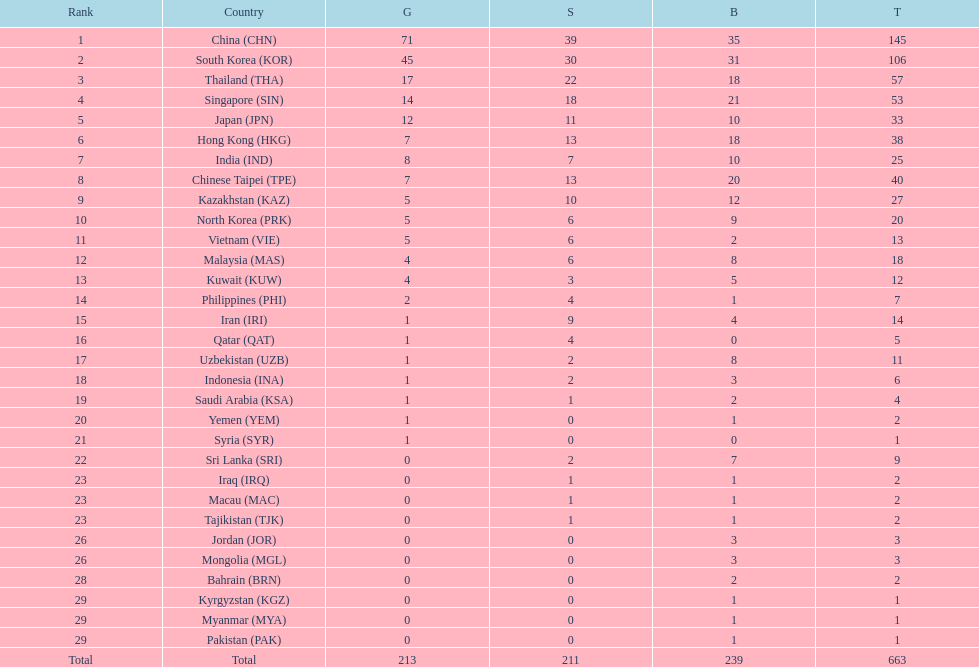How many countries have at least 10 gold medals in the asian youth games? 5. 